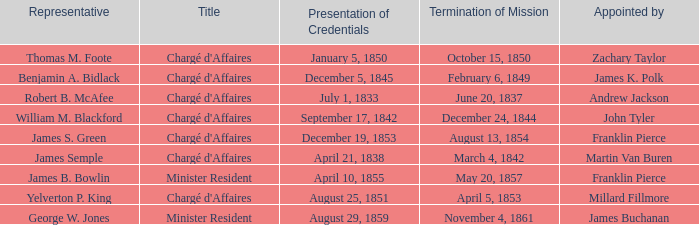What's the Representative listed that has a Presentation of Credentials of August 25, 1851? Yelverton P. King. Write the full table. {'header': ['Representative', 'Title', 'Presentation of Credentials', 'Termination of Mission', 'Appointed by'], 'rows': [['Thomas M. Foote', "Chargé d'Affaires", 'January 5, 1850', 'October 15, 1850', 'Zachary Taylor'], ['Benjamin A. Bidlack', "Chargé d'Affaires", 'December 5, 1845', 'February 6, 1849', 'James K. Polk'], ['Robert B. McAfee', "Chargé d'Affaires", 'July 1, 1833', 'June 20, 1837', 'Andrew Jackson'], ['William M. Blackford', "Chargé d'Affaires", 'September 17, 1842', 'December 24, 1844', 'John Tyler'], ['James S. Green', "Chargé d'Affaires", 'December 19, 1853', 'August 13, 1854', 'Franklin Pierce'], ['James Semple', "Chargé d'Affaires", 'April 21, 1838', 'March 4, 1842', 'Martin Van Buren'], ['James B. Bowlin', 'Minister Resident', 'April 10, 1855', 'May 20, 1857', 'Franklin Pierce'], ['Yelverton P. King', "Chargé d'Affaires", 'August 25, 1851', 'April 5, 1853', 'Millard Fillmore'], ['George W. Jones', 'Minister Resident', 'August 29, 1859', 'November 4, 1861', 'James Buchanan']]} 